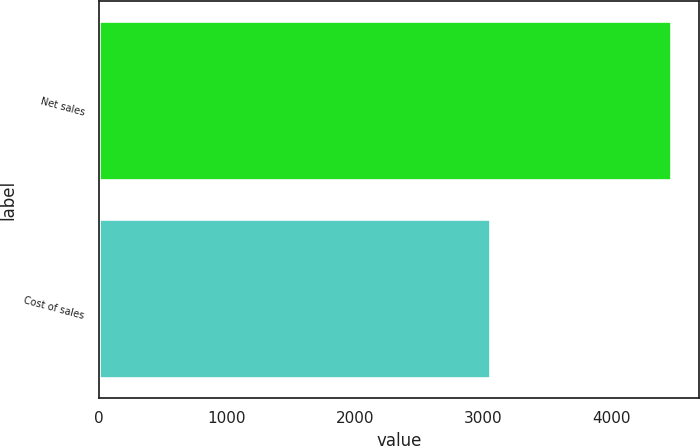<chart> <loc_0><loc_0><loc_500><loc_500><bar_chart><fcel>Net sales<fcel>Cost of sales<nl><fcel>4461.6<fcel>3049.5<nl></chart> 